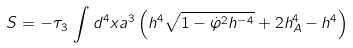Convert formula to latex. <formula><loc_0><loc_0><loc_500><loc_500>S = - \tau _ { 3 } \, \int d ^ { 4 } x a ^ { 3 } \left ( h ^ { 4 } \sqrt { 1 - \dot { \varphi } ^ { 2 } h ^ { - 4 } } + 2 h _ { A } ^ { 4 } - h ^ { 4 } \right )</formula> 